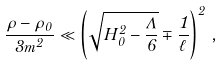Convert formula to latex. <formula><loc_0><loc_0><loc_500><loc_500>\frac { \rho - \rho _ { 0 } } { 3 m ^ { 2 } } \ll \left ( \sqrt { H _ { 0 } ^ { 2 } - \frac { \Lambda } { 6 } } \mp \frac { 1 } { \ell } \right ) ^ { 2 } \, ,</formula> 